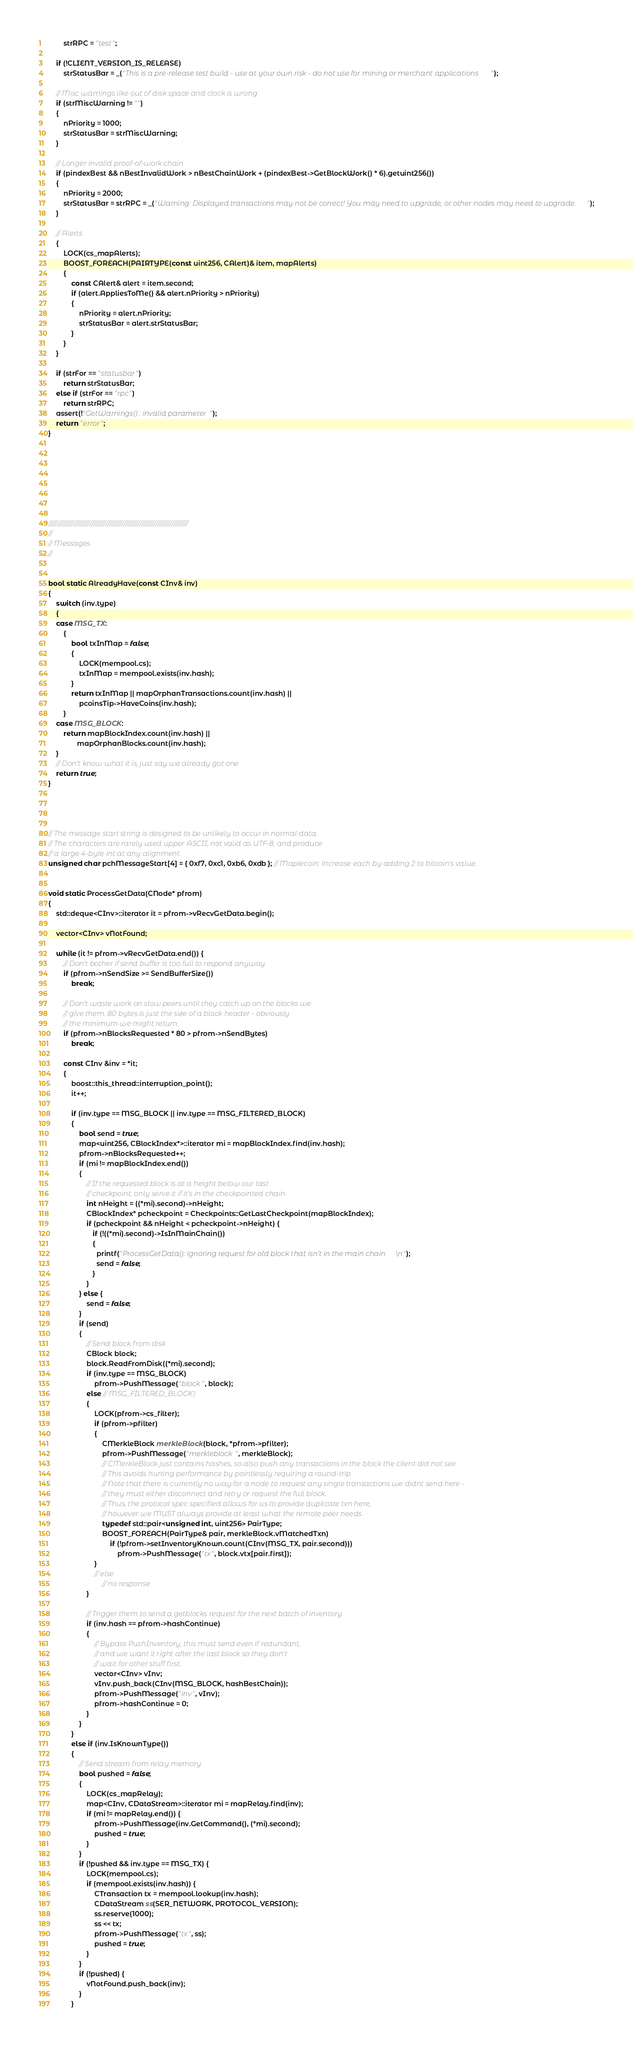<code> <loc_0><loc_0><loc_500><loc_500><_C++_>        strRPC = "test";

    if (!CLIENT_VERSION_IS_RELEASE)
        strStatusBar = _("This is a pre-release test build - use at your own risk - do not use for mining or merchant applications");

    // Misc warnings like out of disk space and clock is wrong
    if (strMiscWarning != "")
    {
        nPriority = 1000;
        strStatusBar = strMiscWarning;
    }

    // Longer invalid proof-of-work chain
    if (pindexBest && nBestInvalidWork > nBestChainWork + (pindexBest->GetBlockWork() * 6).getuint256())
    {
        nPriority = 2000;
        strStatusBar = strRPC = _("Warning: Displayed transactions may not be correct! You may need to upgrade, or other nodes may need to upgrade.");
    }

    // Alerts
    {
        LOCK(cs_mapAlerts);
        BOOST_FOREACH(PAIRTYPE(const uint256, CAlert)& item, mapAlerts)
        {
            const CAlert& alert = item.second;
            if (alert.AppliesToMe() && alert.nPriority > nPriority)
            {
                nPriority = alert.nPriority;
                strStatusBar = alert.strStatusBar;
            }
        }
    }

    if (strFor == "statusbar")
        return strStatusBar;
    else if (strFor == "rpc")
        return strRPC;
    assert(!"GetWarnings() : invalid parameter");
    return "error";
}








//////////////////////////////////////////////////////////////////////////////
//
// Messages
//


bool static AlreadyHave(const CInv& inv)
{
    switch (inv.type)
    {
    case MSG_TX:
        {
            bool txInMap = false;
            {
                LOCK(mempool.cs);
                txInMap = mempool.exists(inv.hash);
            }
            return txInMap || mapOrphanTransactions.count(inv.hash) ||
                pcoinsTip->HaveCoins(inv.hash);
        }
    case MSG_BLOCK:
        return mapBlockIndex.count(inv.hash) ||
               mapOrphanBlocks.count(inv.hash);
    }
    // Don't know what it is, just say we already got one
    return true;
}




// The message start string is designed to be unlikely to occur in normal data.
// The characters are rarely used upper ASCII, not valid as UTF-8, and produce
// a large 4-byte int at any alignment.
unsigned char pchMessageStart[4] = { 0xf7, 0xc1, 0xb6, 0xdb }; // Maplecoin: increase each by adding 2 to bitcoin's value.


void static ProcessGetData(CNode* pfrom)
{
    std::deque<CInv>::iterator it = pfrom->vRecvGetData.begin();

    vector<CInv> vNotFound;

    while (it != pfrom->vRecvGetData.end()) {
        // Don't bother if send buffer is too full to respond anyway
        if (pfrom->nSendSize >= SendBufferSize())
            break;

        // Don't waste work on slow peers until they catch up on the blocks we
        // give them. 80 bytes is just the size of a block header - obviously
        // the minimum we might return.
        if (pfrom->nBlocksRequested * 80 > pfrom->nSendBytes)
            break;

        const CInv &inv = *it;
        {
            boost::this_thread::interruption_point();
            it++;

            if (inv.type == MSG_BLOCK || inv.type == MSG_FILTERED_BLOCK)
            {
                bool send = true;
                map<uint256, CBlockIndex*>::iterator mi = mapBlockIndex.find(inv.hash);
                pfrom->nBlocksRequested++;
                if (mi != mapBlockIndex.end())
                {
                    // If the requested block is at a height below our last
                    // checkpoint, only serve it if it's in the checkpointed chain
                    int nHeight = ((*mi).second)->nHeight;
                    CBlockIndex* pcheckpoint = Checkpoints::GetLastCheckpoint(mapBlockIndex);
                    if (pcheckpoint && nHeight < pcheckpoint->nHeight) {
                       if (!((*mi).second)->IsInMainChain())
                       {
                         printf("ProcessGetData(): ignoring request for old block that isn't in the main chain\n");
                         send = false;
                       }
                    }
                } else {
                    send = false;
                }
                if (send)
                {
                    // Send block from disk
                    CBlock block;
                    block.ReadFromDisk((*mi).second);
                    if (inv.type == MSG_BLOCK)
                        pfrom->PushMessage("block", block);
                    else // MSG_FILTERED_BLOCK)
                    {
                        LOCK(pfrom->cs_filter);
                        if (pfrom->pfilter)
                        {
                            CMerkleBlock merkleBlock(block, *pfrom->pfilter);
                            pfrom->PushMessage("merkleblock", merkleBlock);
                            // CMerkleBlock just contains hashes, so also push any transactions in the block the client did not see
                            // This avoids hurting performance by pointlessly requiring a round-trip
                            // Note that there is currently no way for a node to request any single transactions we didnt send here -
                            // they must either disconnect and retry or request the full block.
                            // Thus, the protocol spec specified allows for us to provide duplicate txn here,
                            // however we MUST always provide at least what the remote peer needs
                            typedef std::pair<unsigned int, uint256> PairType;
                            BOOST_FOREACH(PairType& pair, merkleBlock.vMatchedTxn)
                                if (!pfrom->setInventoryKnown.count(CInv(MSG_TX, pair.second)))
                                    pfrom->PushMessage("tx", block.vtx[pair.first]);
                        }
                        // else
                            // no response
                    }

                    // Trigger them to send a getblocks request for the next batch of inventory
                    if (inv.hash == pfrom->hashContinue)
                    {
                        // Bypass PushInventory, this must send even if redundant,
                        // and we want it right after the last block so they don't
                        // wait for other stuff first.
                        vector<CInv> vInv;
                        vInv.push_back(CInv(MSG_BLOCK, hashBestChain));
                        pfrom->PushMessage("inv", vInv);
                        pfrom->hashContinue = 0;
                    }
                }
            }
            else if (inv.IsKnownType())
            {
                // Send stream from relay memory
                bool pushed = false;
                {
                    LOCK(cs_mapRelay);
                    map<CInv, CDataStream>::iterator mi = mapRelay.find(inv);
                    if (mi != mapRelay.end()) {
                        pfrom->PushMessage(inv.GetCommand(), (*mi).second);
                        pushed = true;
                    }
                }
                if (!pushed && inv.type == MSG_TX) {
                    LOCK(mempool.cs);
                    if (mempool.exists(inv.hash)) {
                        CTransaction tx = mempool.lookup(inv.hash);
                        CDataStream ss(SER_NETWORK, PROTOCOL_VERSION);
                        ss.reserve(1000);
                        ss << tx;
                        pfrom->PushMessage("tx", ss);
                        pushed = true;
                    }
                }
                if (!pushed) {
                    vNotFound.push_back(inv);
                }
            }
</code> 